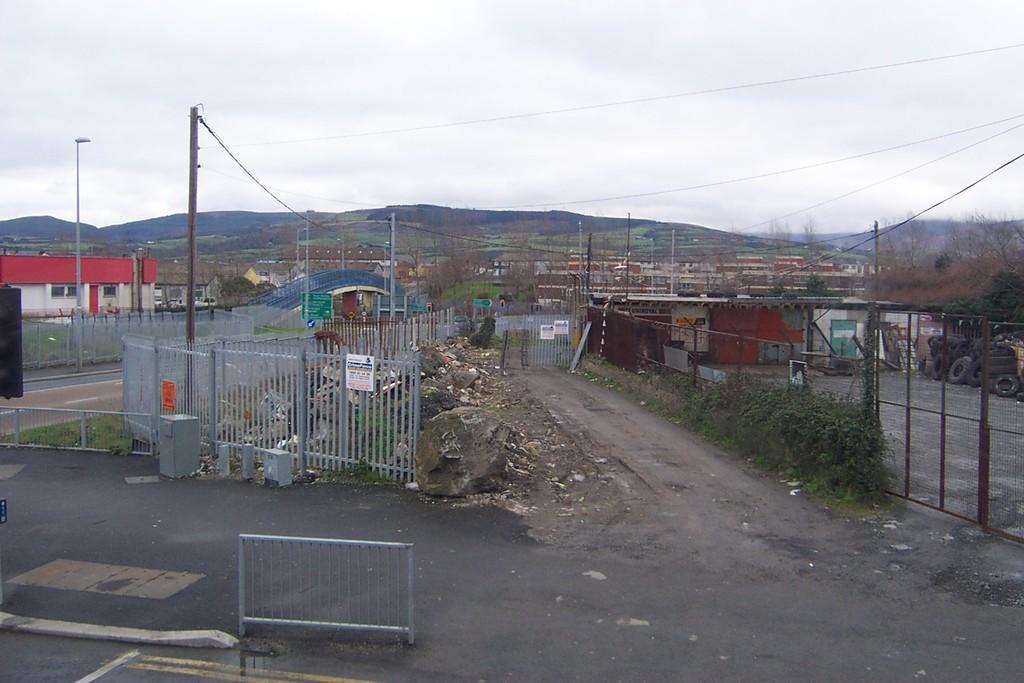Describe this image in one or two sentences. In the foreground of the image we can see a metal railing. On the right side of the image we can see a metal fence, a group of plants, tyres. To the left side of the image we can see a building, group of poles, bridge. In the background, we can see a group of trees, buildings, mountains and sky. 